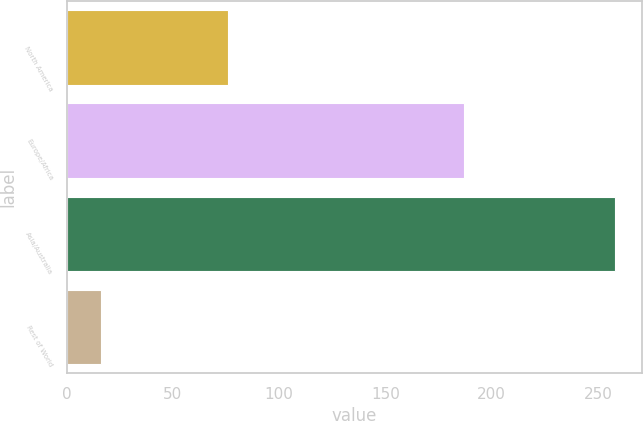Convert chart to OTSL. <chart><loc_0><loc_0><loc_500><loc_500><bar_chart><fcel>North America<fcel>Europe/Africa<fcel>Asia/Australia<fcel>Rest of World<nl><fcel>76<fcel>187<fcel>258<fcel>16<nl></chart> 